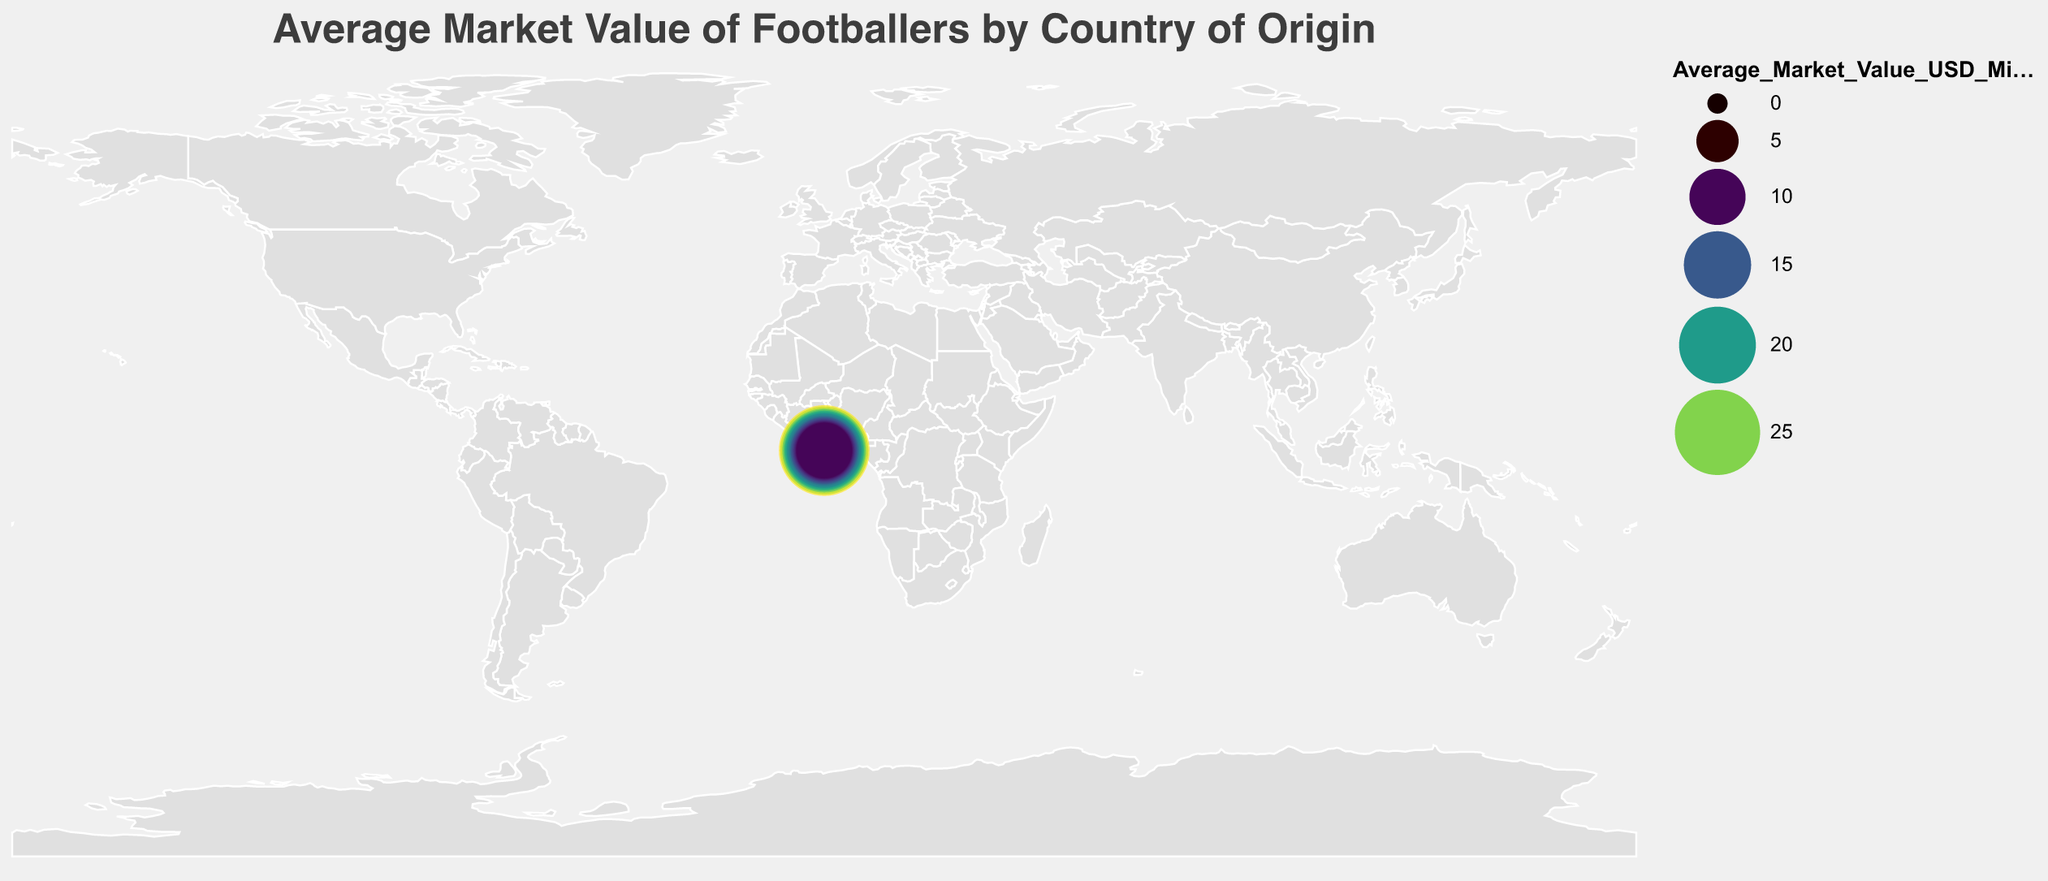What is the title of the figure? The title of the figure is displayed at the top. It reads, "Average Market Value of Footballers by Country of Origin".
Answer: Average Market Value of Footballers by Country of Origin Which country has the highest average market value for football players? The figure displays circles of varying sizes and colors for different countries. The country with the largest and most prominently colored circle is Brazil.
Answer: Brazil How does the average market value of football players from Sweden compare to that of France? By observing the sizes and color intensity of the circles for both Sweden and France, it is evident that the average market value in France (26.7 million USD) is higher than that in Sweden (12.5 million USD).
Answer: France has a higher average market value What is the average market value of football players from Italy and the Netherlands combined? The figure indicates that Italy has an average market value of 18.7 million USD and the Netherlands has 17.9 million USD. Adding these values gives 18.7 + 17.9 = 36.6 million USD.
Answer: 36.6 million USD Which country between Argentina and Germany has a lower average market value of football players? By comparing the circles for Argentina and Germany, it can be seen that Argentina has a market value of 20.8 million USD while Germany's is 21.6 million USD. Thus, Argentina has a lower average market value.
Answer: Argentina What is the total number of countries displayed in the figure? The figure shows circles representing different countries and there are 20 distinct circles, each corresponding to a country.
Answer: 20 By how much does the average market value of football players from Brazil exceed that of Nigeria? The average market value for Brazil is 28.5 million USD and for Nigeria, it is 9.8 million USD. Subtracting these values we get 28.5 - 9.8 = 18.7 million USD.
Answer: 18.7 million USD What is the rank of Spain in terms of average market value among the displayed countries? Observing the average market values in descending order: Brazil (28.5), France (26.7), England (24.3), and then Spain with 22.9 million USD, Spain is the 4th in rank.
Answer: 4th Between Croatia and Denmark, which country has the higher average market value? Comparing the circles for Croatia (15.2 million USD) and Denmark (13.1 million USD), Croatia has the higher average market value.
Answer: Croatia 